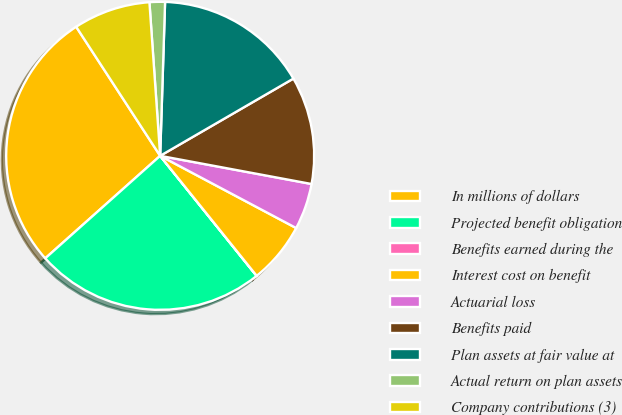Convert chart. <chart><loc_0><loc_0><loc_500><loc_500><pie_chart><fcel>In millions of dollars<fcel>Projected benefit obligation<fcel>Benefits earned during the<fcel>Interest cost on benefit<fcel>Actuarial loss<fcel>Benefits paid<fcel>Plan assets at fair value at<fcel>Actual return on plan assets<fcel>Company contributions (3)<nl><fcel>27.41%<fcel>24.18%<fcel>0.01%<fcel>6.45%<fcel>4.84%<fcel>11.29%<fcel>16.13%<fcel>1.62%<fcel>8.07%<nl></chart> 